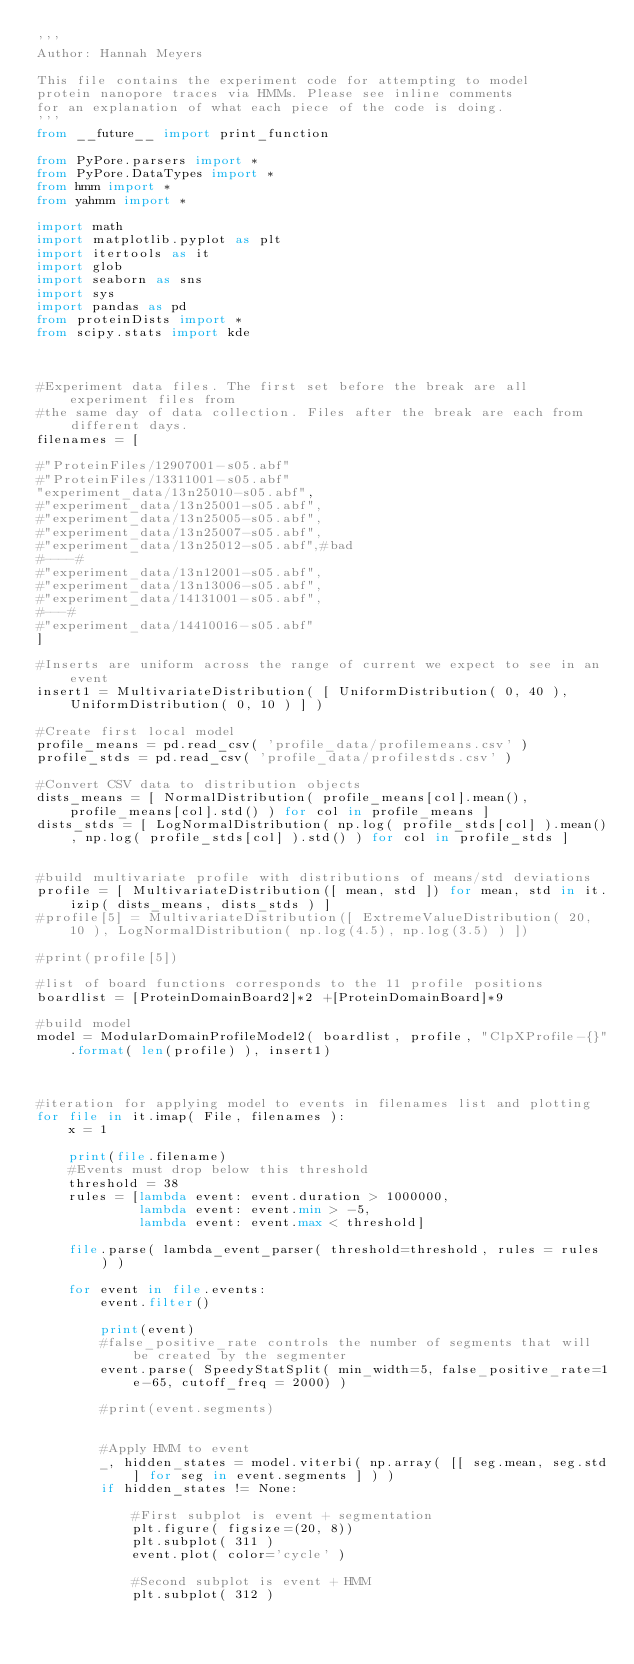<code> <loc_0><loc_0><loc_500><loc_500><_Python_>'''
Author: Hannah Meyers

This file contains the experiment code for attempting to model
protein nanopore traces via HMMs. Please see inline comments
for an explanation of what each piece of the code is doing.
'''
from __future__ import print_function

from PyPore.parsers import *
from PyPore.DataTypes import *
from hmm import *
from yahmm import *

import math
import matplotlib.pyplot as plt
import itertools as it
import glob
import seaborn as sns
import sys
import pandas as pd
from proteinDists import *
from scipy.stats import kde



#Experiment data files. The first set before the break are all experiment files from
#the same day of data collection. Files after the break are each from different days.
filenames = [

#"ProteinFiles/12907001-s05.abf"
#"ProteinFiles/13311001-s05.abf"
"experiment_data/13n25010-s05.abf",
#"experiment_data/13n25001-s05.abf",
#"experiment_data/13n25005-s05.abf",
#"experiment_data/13n25007-s05.abf",
#"experiment_data/13n25012-s05.abf",#bad
#----#
#"experiment_data/13n12001-s05.abf",
#"experiment_data/13n13006-s05.abf",
#"experiment_data/14131001-s05.abf",
#---#
#"experiment_data/14410016-s05.abf"
] 

#Inserts are uniform across the range of current we expect to see in an event
insert1 = MultivariateDistribution( [ UniformDistribution( 0, 40 ), UniformDistribution( 0, 10 ) ] )

#Create first local model
profile_means = pd.read_csv( 'profile_data/profilemeans.csv' )
profile_stds = pd.read_csv( 'profile_data/profilestds.csv' )

#Convert CSV data to distribution objects
dists_means = [ NormalDistribution( profile_means[col].mean(), profile_means[col].std() ) for col in profile_means ] 
dists_stds = [ LogNormalDistribution( np.log( profile_stds[col] ).mean(), np.log( profile_stds[col] ).std() ) for col in profile_stds ]


#build multivariate profile with distributions of means/std deviations
profile = [ MultivariateDistribution([ mean, std ]) for mean, std in it.izip( dists_means, dists_stds ) ]
#profile[5] = MultivariateDistribution([ ExtremeValueDistribution( 20, 10 ), LogNormalDistribution( np.log(4.5), np.log(3.5) ) ])

#print(profile[5])

#list of board functions corresponds to the 11 profile positions
boardlist = [ProteinDomainBoard2]*2 +[ProteinDomainBoard]*9

#build model
model = ModularDomainProfileModel2( boardlist, profile, "ClpXProfile-{}".format( len(profile) ), insert1)



#iteration for applying model to events in filenames list and plotting
for file in it.imap( File, filenames ):
    x = 1
    
    print(file.filename)
    #Events must drop below this threshold
    threshold = 38
    rules = [lambda event: event.duration > 1000000,
             lambda event: event.min > -5,
             lambda event: event.max < threshold]
    
    file.parse( lambda_event_parser( threshold=threshold, rules = rules ) )
    
    for event in file.events:
        event.filter()
        
        print(event)
        #false_positive_rate controls the number of segments that will be created by the segmenter
        event.parse( SpeedyStatSplit( min_width=5, false_positive_rate=1e-65, cutoff_freq = 2000) )
        
        #print(event.segments)
        
        
        #Apply HMM to event
        _, hidden_states = model.viterbi( np.array( [[ seg.mean, seg.std] for seg in event.segments ] ) )
        if hidden_states != None:
            
            #First subplot is event + segmentation
            plt.figure( figsize=(20, 8))
            plt.subplot( 311 )
            event.plot( color='cycle' )

            #Second subplot is event + HMM
            plt.subplot( 312 )</code> 